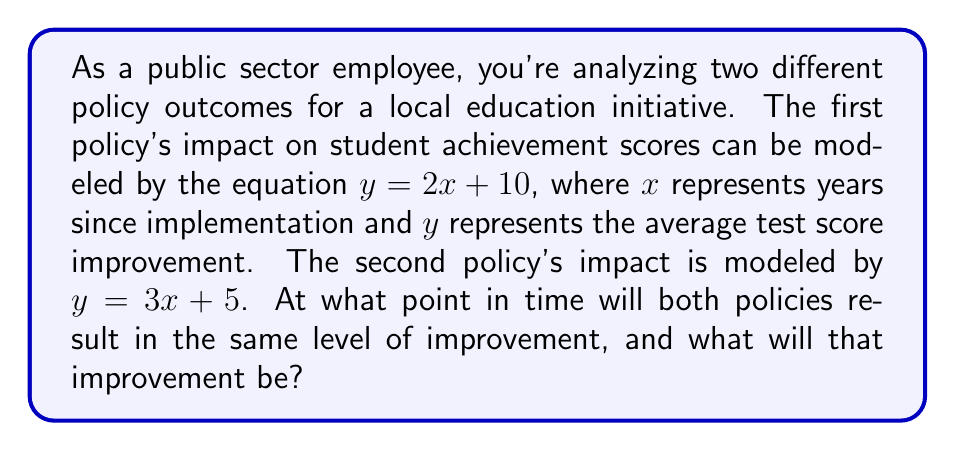Show me your answer to this math problem. To find the intersection point of these two linear equations, we need to solve them simultaneously:

1) First equation: $y = 2x + 10$
2) Second equation: $y = 3x + 5$

3) At the intersection point, both equations are equal, so:
   $2x + 10 = 3x + 5$

4) Subtract $2x$ from both sides:
   $10 = x + 5$

5) Subtract 5 from both sides:
   $5 = x$

6) Now that we know $x$, we can substitute it into either equation to find $y$. Let's use the first equation:
   $y = 2(5) + 10$
   $y = 10 + 10 = 20$

Therefore, the policies will result in the same level of improvement after 5 years, with an improvement of 20 points in the average test score.
Answer: $(5, 20)$ 